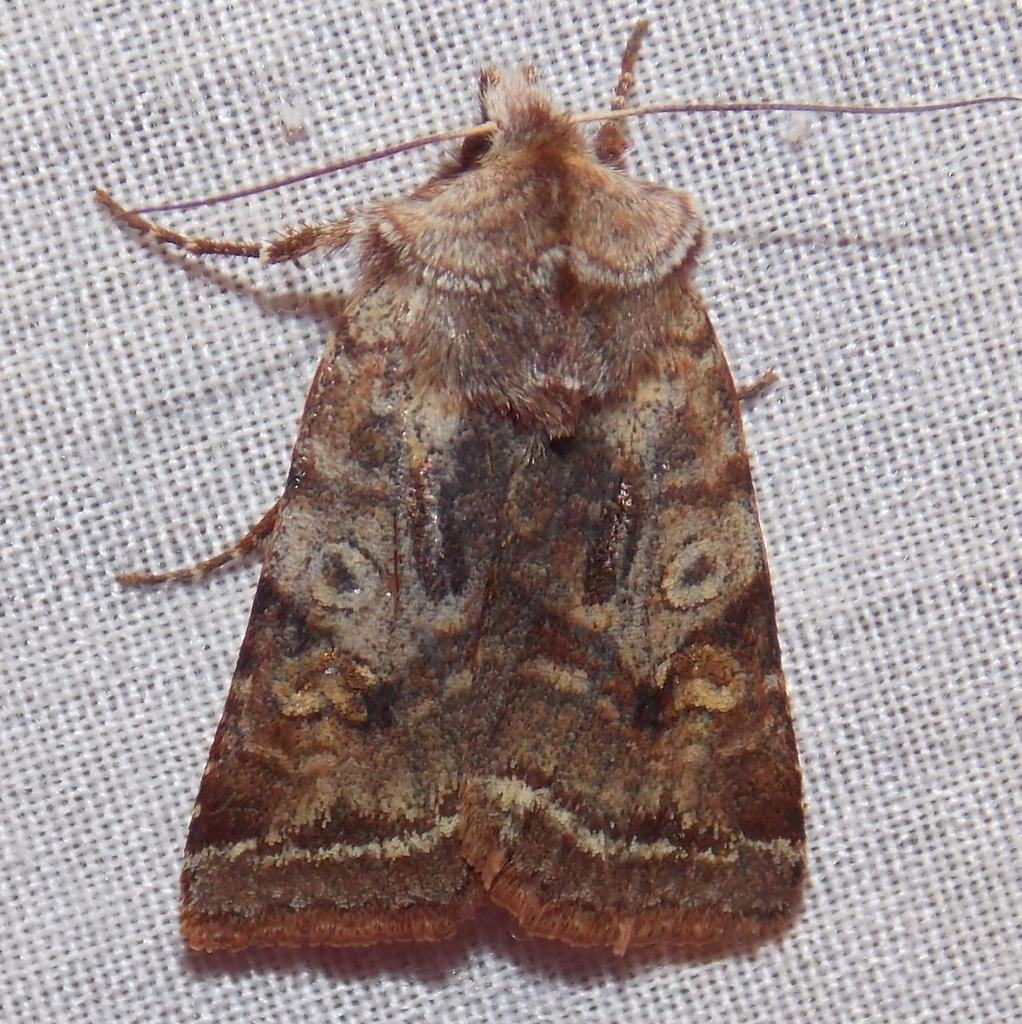What type of creature is present in the image? There is an insect in the image. Where is the insect located? The insect is on a surface. What type of marble is being used for the chessboard in the image? There is no chessboard or marble present in the image; it features an insect on a surface. 